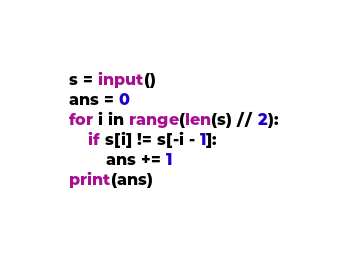<code> <loc_0><loc_0><loc_500><loc_500><_Python_>s = input()
ans = 0
for i in range(len(s) // 2):
    if s[i] != s[-i - 1]:
        ans += 1
print(ans)</code> 